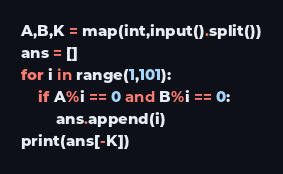<code> <loc_0><loc_0><loc_500><loc_500><_Python_>A,B,K = map(int,input().split())
ans = []
for i in range(1,101):
    if A%i == 0 and B%i == 0:
        ans.append(i)
print(ans[-K])</code> 